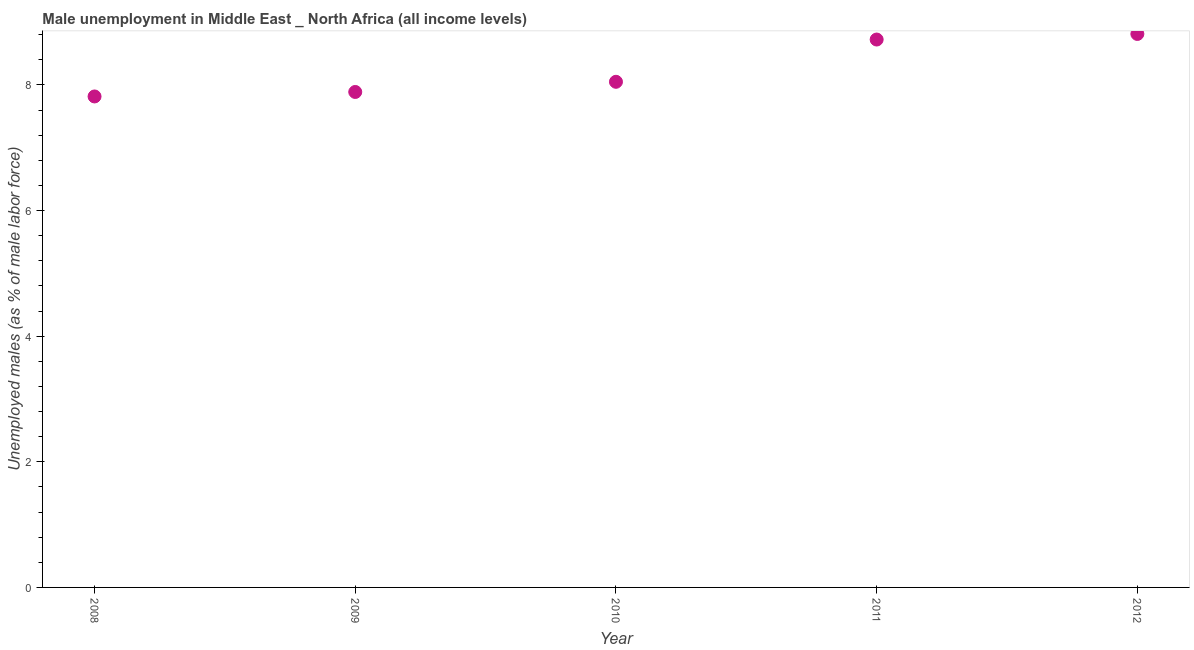What is the unemployed males population in 2012?
Provide a short and direct response. 8.81. Across all years, what is the maximum unemployed males population?
Your answer should be compact. 8.81. Across all years, what is the minimum unemployed males population?
Give a very brief answer. 7.82. What is the sum of the unemployed males population?
Give a very brief answer. 41.29. What is the difference between the unemployed males population in 2009 and 2010?
Make the answer very short. -0.16. What is the average unemployed males population per year?
Keep it short and to the point. 8.26. What is the median unemployed males population?
Offer a very short reply. 8.05. In how many years, is the unemployed males population greater than 8.4 %?
Offer a terse response. 2. Do a majority of the years between 2012 and 2011 (inclusive) have unemployed males population greater than 7.6 %?
Your response must be concise. No. What is the ratio of the unemployed males population in 2009 to that in 2010?
Provide a succinct answer. 0.98. Is the difference between the unemployed males population in 2009 and 2011 greater than the difference between any two years?
Ensure brevity in your answer.  No. What is the difference between the highest and the second highest unemployed males population?
Provide a succinct answer. 0.09. What is the difference between the highest and the lowest unemployed males population?
Provide a succinct answer. 1. How many dotlines are there?
Give a very brief answer. 1. What is the difference between two consecutive major ticks on the Y-axis?
Offer a very short reply. 2. Are the values on the major ticks of Y-axis written in scientific E-notation?
Make the answer very short. No. Does the graph contain any zero values?
Provide a succinct answer. No. Does the graph contain grids?
Keep it short and to the point. No. What is the title of the graph?
Your response must be concise. Male unemployment in Middle East _ North Africa (all income levels). What is the label or title of the X-axis?
Keep it short and to the point. Year. What is the label or title of the Y-axis?
Ensure brevity in your answer.  Unemployed males (as % of male labor force). What is the Unemployed males (as % of male labor force) in 2008?
Provide a succinct answer. 7.82. What is the Unemployed males (as % of male labor force) in 2009?
Ensure brevity in your answer.  7.89. What is the Unemployed males (as % of male labor force) in 2010?
Make the answer very short. 8.05. What is the Unemployed males (as % of male labor force) in 2011?
Your response must be concise. 8.72. What is the Unemployed males (as % of male labor force) in 2012?
Give a very brief answer. 8.81. What is the difference between the Unemployed males (as % of male labor force) in 2008 and 2009?
Offer a terse response. -0.07. What is the difference between the Unemployed males (as % of male labor force) in 2008 and 2010?
Make the answer very short. -0.23. What is the difference between the Unemployed males (as % of male labor force) in 2008 and 2011?
Ensure brevity in your answer.  -0.91. What is the difference between the Unemployed males (as % of male labor force) in 2008 and 2012?
Ensure brevity in your answer.  -1. What is the difference between the Unemployed males (as % of male labor force) in 2009 and 2010?
Your answer should be compact. -0.16. What is the difference between the Unemployed males (as % of male labor force) in 2009 and 2011?
Ensure brevity in your answer.  -0.83. What is the difference between the Unemployed males (as % of male labor force) in 2009 and 2012?
Offer a very short reply. -0.92. What is the difference between the Unemployed males (as % of male labor force) in 2010 and 2011?
Offer a very short reply. -0.67. What is the difference between the Unemployed males (as % of male labor force) in 2010 and 2012?
Offer a terse response. -0.76. What is the difference between the Unemployed males (as % of male labor force) in 2011 and 2012?
Give a very brief answer. -0.09. What is the ratio of the Unemployed males (as % of male labor force) in 2008 to that in 2011?
Your answer should be very brief. 0.9. What is the ratio of the Unemployed males (as % of male labor force) in 2008 to that in 2012?
Provide a succinct answer. 0.89. What is the ratio of the Unemployed males (as % of male labor force) in 2009 to that in 2011?
Provide a succinct answer. 0.9. What is the ratio of the Unemployed males (as % of male labor force) in 2009 to that in 2012?
Ensure brevity in your answer.  0.9. What is the ratio of the Unemployed males (as % of male labor force) in 2010 to that in 2011?
Offer a terse response. 0.92. What is the ratio of the Unemployed males (as % of male labor force) in 2010 to that in 2012?
Your answer should be very brief. 0.91. 